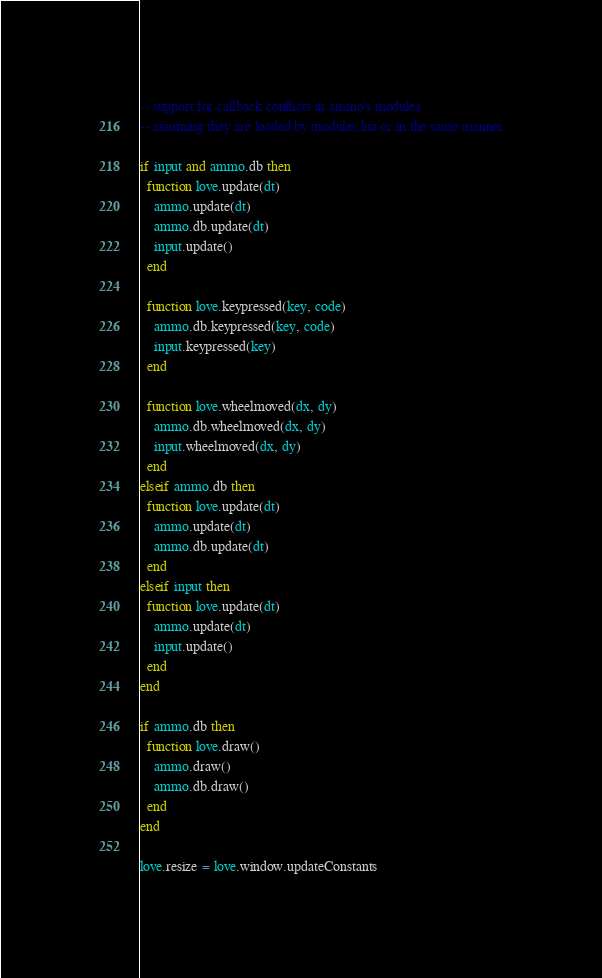<code> <loc_0><loc_0><loc_500><loc_500><_Lua_>-- support for callback conflicts in ammo's modules
-- assuming they are loaded by modules.lua or in the same manner

if input and ammo.db then
  function love.update(dt)
    ammo.update(dt)
    ammo.db.update(dt)
    input.update()
  end

  function love.keypressed(key, code)
    ammo.db.keypressed(key, code)
    input.keypressed(key)
  end

  function love.wheelmoved(dx, dy)
    ammo.db.wheelmoved(dx, dy)
    input.wheelmoved(dx, dy)
  end
elseif ammo.db then
  function love.update(dt)
    ammo.update(dt)
    ammo.db.update(dt)
  end
elseif input then
  function love.update(dt)
    ammo.update(dt)
    input.update()
  end
end

if ammo.db then
  function love.draw()
    ammo.draw()
    ammo.db.draw()
  end
end

love.resize = love.window.updateConstants
</code> 